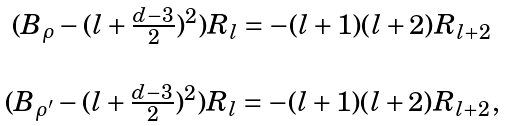<formula> <loc_0><loc_0><loc_500><loc_500>\begin{array} { c } ( B _ { \rho } - ( l + \frac { d - 3 } { 2 } ) ^ { 2 } ) R _ { l } = - ( l + 1 ) ( l + 2 ) R _ { l + 2 } \\ \\ ( B _ { \rho ^ { \prime } } - ( l + \frac { d - 3 } { 2 } ) ^ { 2 } ) R _ { l } = - ( l + 1 ) ( l + 2 ) R _ { l + 2 } , \end{array}</formula> 